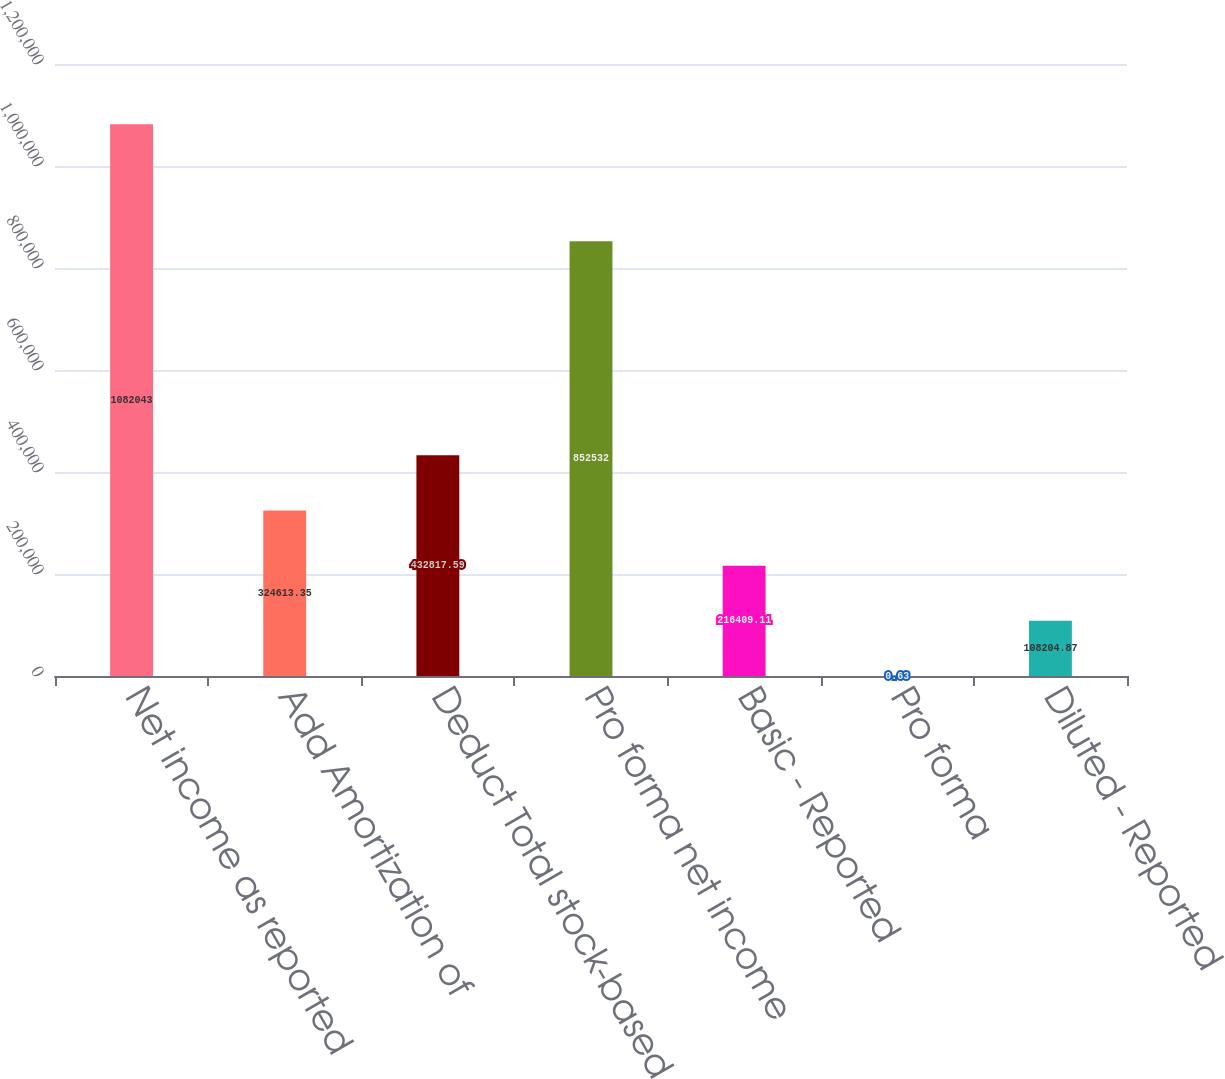Convert chart. <chart><loc_0><loc_0><loc_500><loc_500><bar_chart><fcel>Net income as reported<fcel>Add Amortization of<fcel>Deduct Total stock-based<fcel>Pro forma net income<fcel>Basic - Reported<fcel>Pro forma<fcel>Diluted - Reported<nl><fcel>1.08204e+06<fcel>324613<fcel>432818<fcel>852532<fcel>216409<fcel>0.63<fcel>108205<nl></chart> 